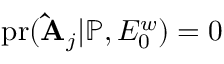Convert formula to latex. <formula><loc_0><loc_0><loc_500><loc_500>p r ( \hat { A } _ { j } | \mathbb { P } , E _ { 0 } ^ { w } ) = 0</formula> 